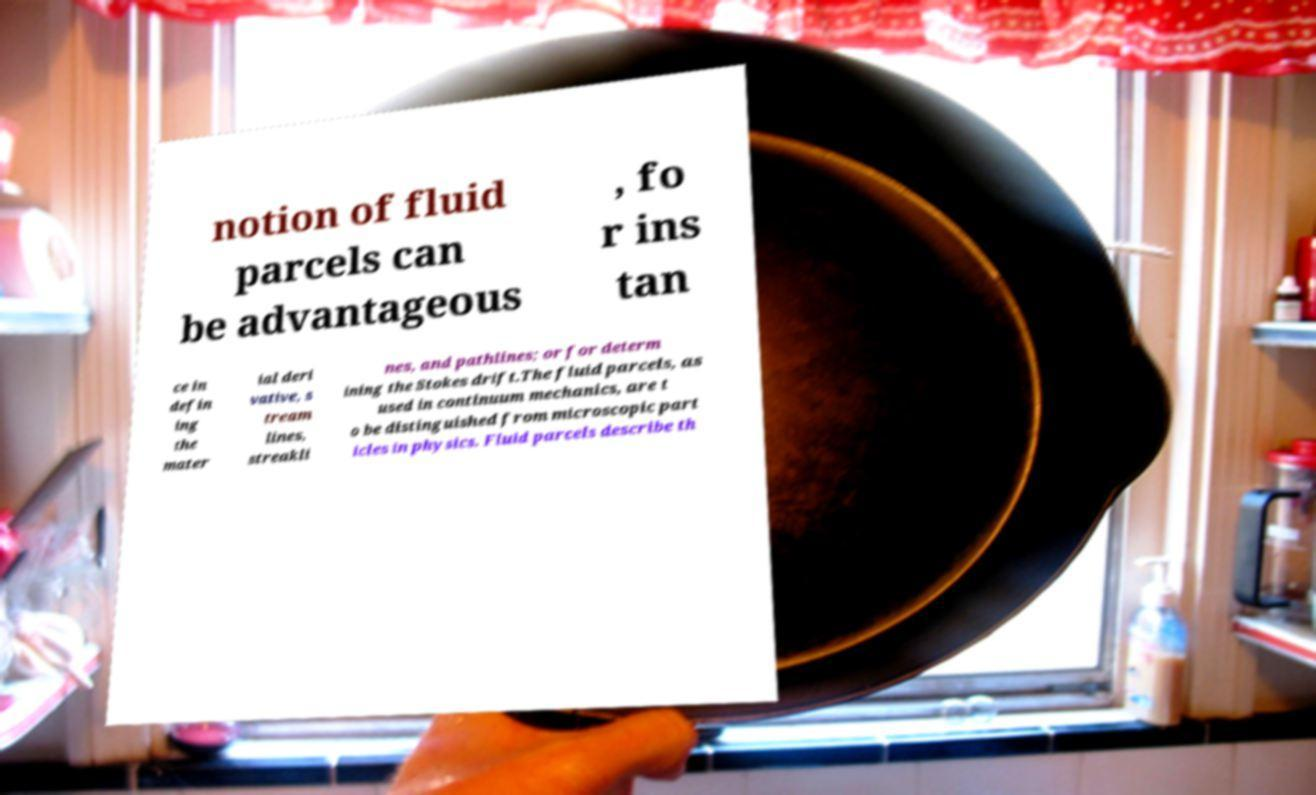Please read and relay the text visible in this image. What does it say? notion of fluid parcels can be advantageous , fo r ins tan ce in defin ing the mater ial deri vative, s tream lines, streakli nes, and pathlines; or for determ ining the Stokes drift.The fluid parcels, as used in continuum mechanics, are t o be distinguished from microscopic part icles in physics. Fluid parcels describe th 